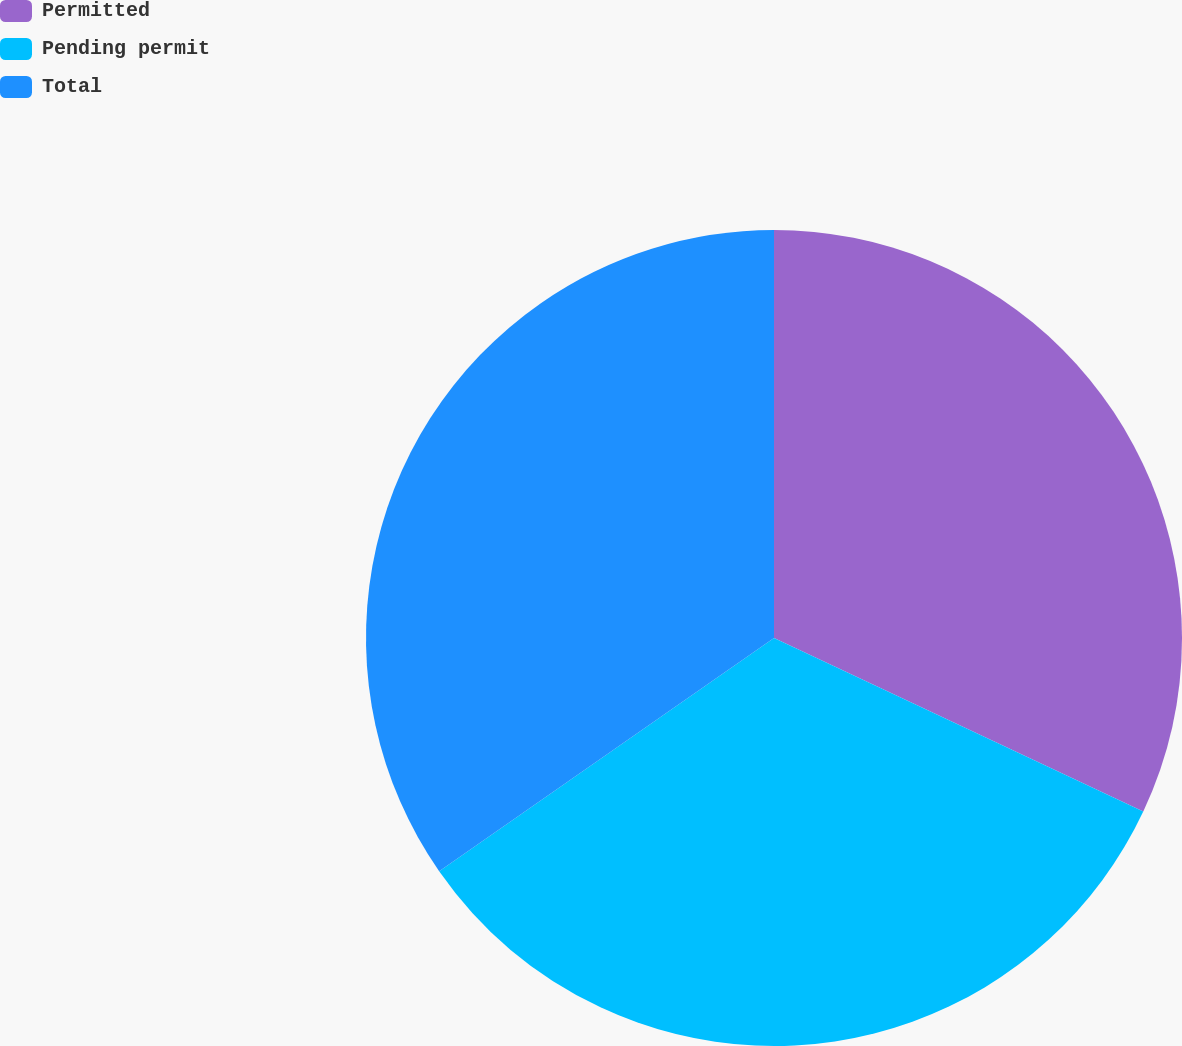Convert chart to OTSL. <chart><loc_0><loc_0><loc_500><loc_500><pie_chart><fcel>Permitted<fcel>Pending permit<fcel>Total<nl><fcel>31.99%<fcel>33.33%<fcel>34.68%<nl></chart> 